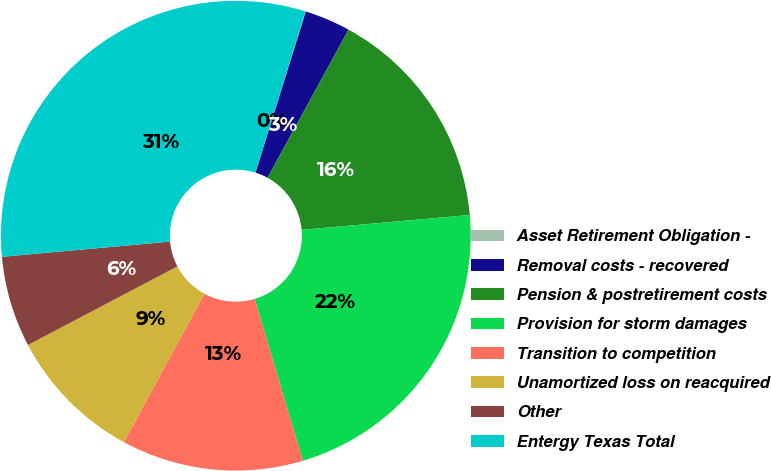Convert chart to OTSL. <chart><loc_0><loc_0><loc_500><loc_500><pie_chart><fcel>Asset Retirement Obligation -<fcel>Removal costs - recovered<fcel>Pension & postretirement costs<fcel>Provision for storm damages<fcel>Transition to competition<fcel>Unamortized loss on reacquired<fcel>Other<fcel>Entergy Texas Total<nl><fcel>0.03%<fcel>3.15%<fcel>15.63%<fcel>21.8%<fcel>12.51%<fcel>9.39%<fcel>6.27%<fcel>31.22%<nl></chart> 